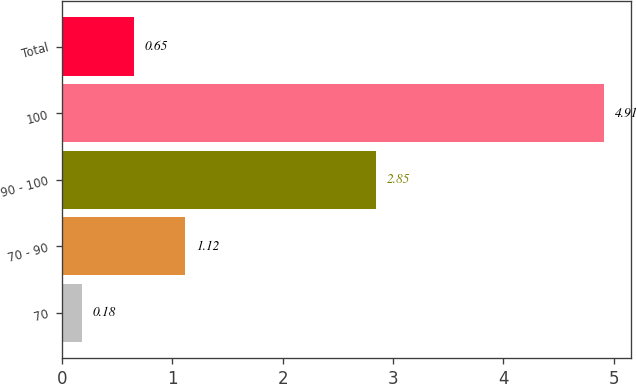Convert chart. <chart><loc_0><loc_0><loc_500><loc_500><bar_chart><fcel>70<fcel>70 - 90<fcel>90 - 100<fcel>100<fcel>Total<nl><fcel>0.18<fcel>1.12<fcel>2.85<fcel>4.91<fcel>0.65<nl></chart> 